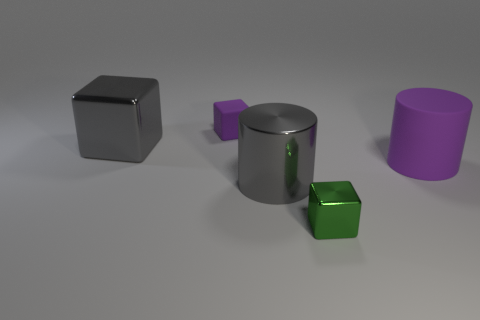The big thing that is both on the left side of the small green metallic block and behind the shiny cylinder is made of what material?
Offer a very short reply. Metal. Are there the same number of green metal objects left of the rubber block and large gray shiny balls?
Ensure brevity in your answer.  Yes. How many objects are large gray metal blocks that are in front of the small purple object or tiny metal balls?
Your answer should be very brief. 1. Does the metal cube that is to the right of the big gray metal block have the same color as the rubber block?
Offer a terse response. No. What is the size of the metallic thing that is in front of the large gray cylinder?
Provide a succinct answer. Small. What is the shape of the rubber thing that is left of the big cylinder that is on the right side of the large gray cylinder?
Your answer should be compact. Cube. What color is the tiny rubber thing that is the same shape as the small green shiny object?
Offer a terse response. Purple. There is a metallic block that is on the left side of the gray metallic cylinder; does it have the same size as the big purple rubber thing?
Keep it short and to the point. Yes. The other matte thing that is the same color as the big rubber object is what shape?
Offer a terse response. Cube. What number of big blocks are made of the same material as the big purple cylinder?
Ensure brevity in your answer.  0. 